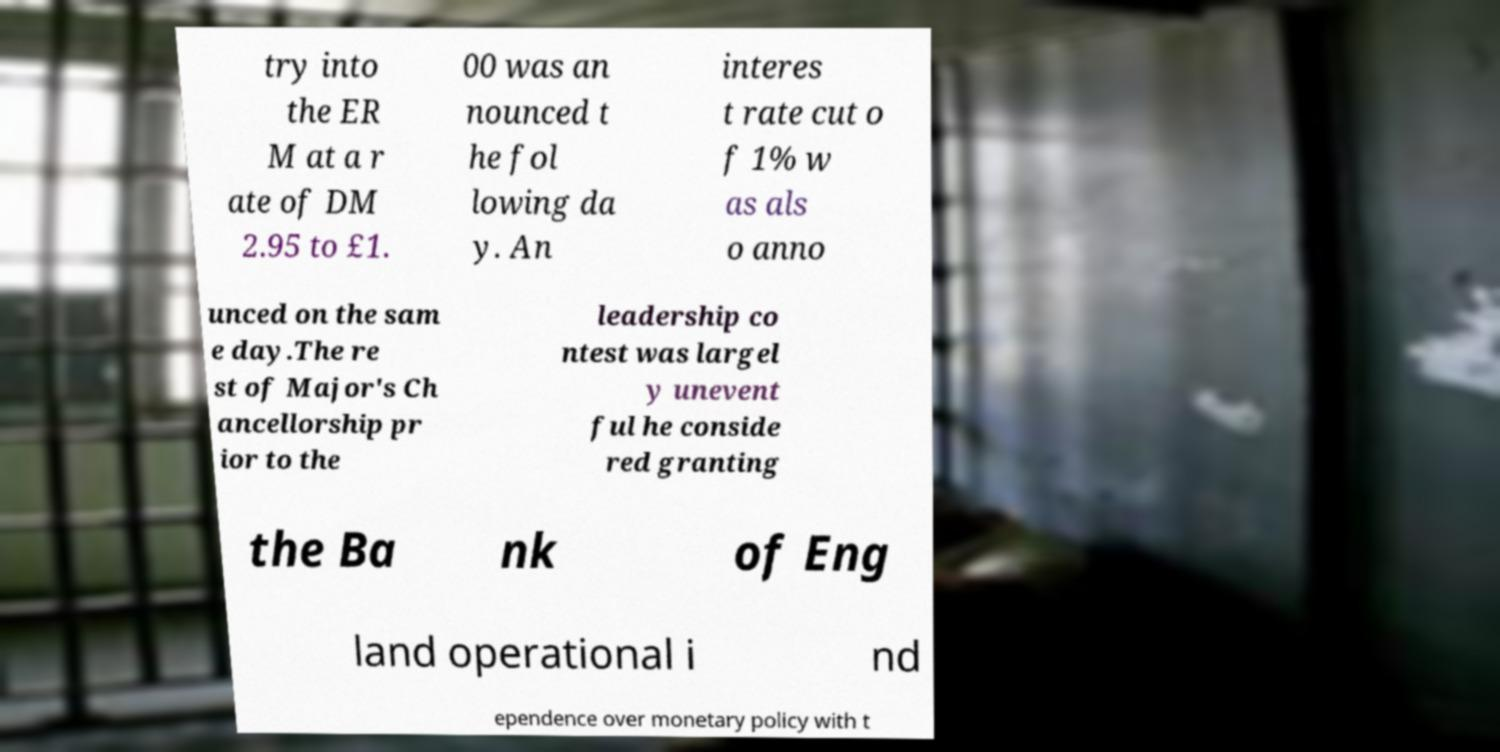Please read and relay the text visible in this image. What does it say? try into the ER M at a r ate of DM 2.95 to £1. 00 was an nounced t he fol lowing da y. An interes t rate cut o f 1% w as als o anno unced on the sam e day.The re st of Major's Ch ancellorship pr ior to the leadership co ntest was largel y unevent ful he conside red granting the Ba nk of Eng land operational i nd ependence over monetary policy with t 